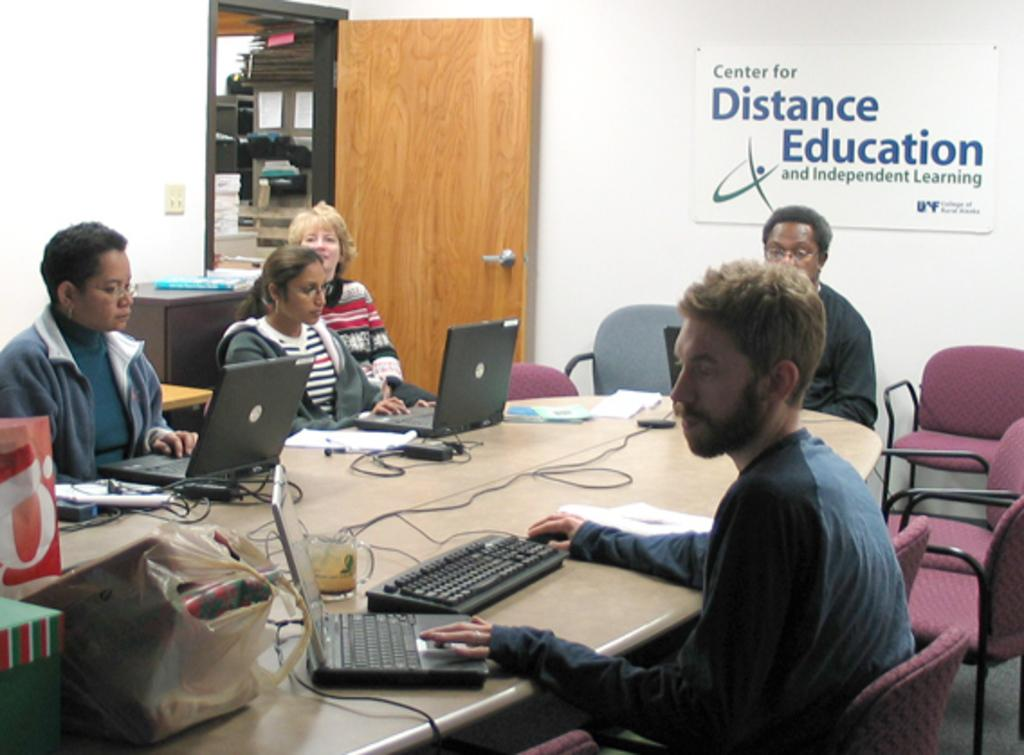Provide a one-sentence caption for the provided image. People in a conference room with a sign reading Center for Distance Education. 